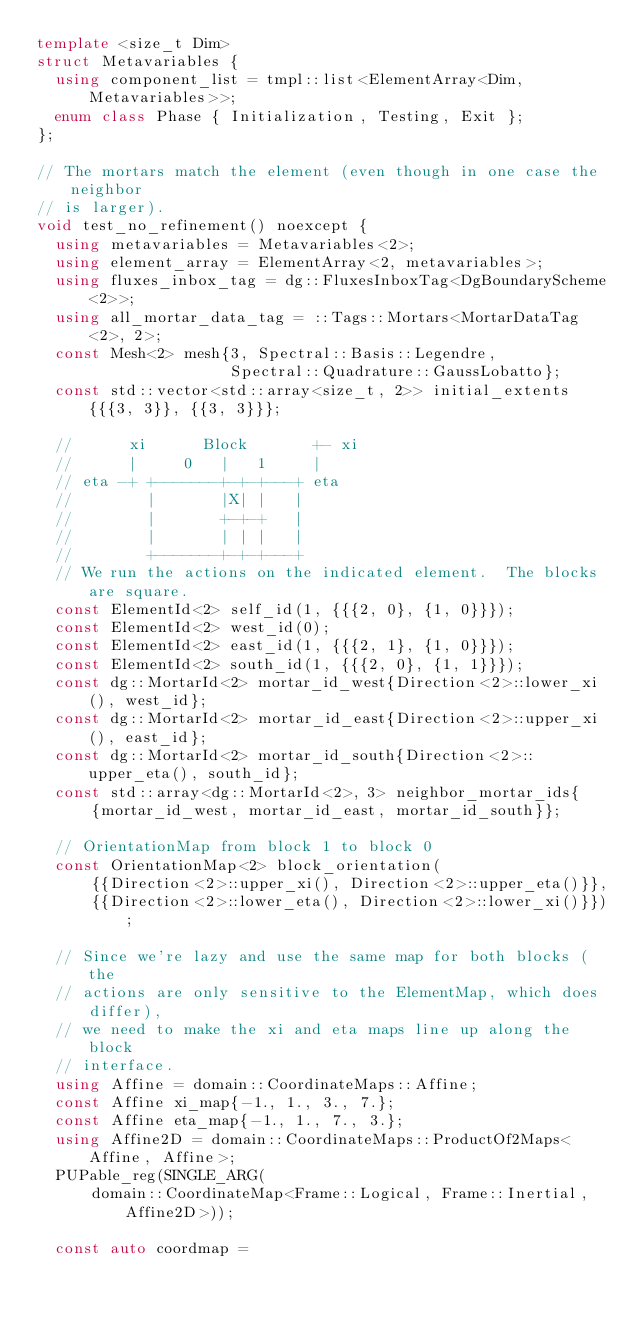<code> <loc_0><loc_0><loc_500><loc_500><_C++_>template <size_t Dim>
struct Metavariables {
  using component_list = tmpl::list<ElementArray<Dim, Metavariables>>;
  enum class Phase { Initialization, Testing, Exit };
};

// The mortars match the element (even though in one case the neighbor
// is larger).
void test_no_refinement() noexcept {
  using metavariables = Metavariables<2>;
  using element_array = ElementArray<2, metavariables>;
  using fluxes_inbox_tag = dg::FluxesInboxTag<DgBoundaryScheme<2>>;
  using all_mortar_data_tag = ::Tags::Mortars<MortarDataTag<2>, 2>;
  const Mesh<2> mesh{3, Spectral::Basis::Legendre,
                     Spectral::Quadrature::GaussLobatto};
  const std::vector<std::array<size_t, 2>> initial_extents{{{3, 3}}, {{3, 3}}};

  //      xi      Block       +- xi
  //      |     0   |   1     |
  // eta -+ +-------+-+-+---+ eta
  //        |       |X| |   |
  //        |       +-+-+   |
  //        |       | | |   |
  //        +-------+-+-+---+
  // We run the actions on the indicated element.  The blocks are square.
  const ElementId<2> self_id(1, {{{2, 0}, {1, 0}}});
  const ElementId<2> west_id(0);
  const ElementId<2> east_id(1, {{{2, 1}, {1, 0}}});
  const ElementId<2> south_id(1, {{{2, 0}, {1, 1}}});
  const dg::MortarId<2> mortar_id_west{Direction<2>::lower_xi(), west_id};
  const dg::MortarId<2> mortar_id_east{Direction<2>::upper_xi(), east_id};
  const dg::MortarId<2> mortar_id_south{Direction<2>::upper_eta(), south_id};
  const std::array<dg::MortarId<2>, 3> neighbor_mortar_ids{
      {mortar_id_west, mortar_id_east, mortar_id_south}};

  // OrientationMap from block 1 to block 0
  const OrientationMap<2> block_orientation(
      {{Direction<2>::upper_xi(), Direction<2>::upper_eta()}},
      {{Direction<2>::lower_eta(), Direction<2>::lower_xi()}});

  // Since we're lazy and use the same map for both blocks (the
  // actions are only sensitive to the ElementMap, which does differ),
  // we need to make the xi and eta maps line up along the block
  // interface.
  using Affine = domain::CoordinateMaps::Affine;
  const Affine xi_map{-1., 1., 3., 7.};
  const Affine eta_map{-1., 1., 7., 3.};
  using Affine2D = domain::CoordinateMaps::ProductOf2Maps<Affine, Affine>;
  PUPable_reg(SINGLE_ARG(
      domain::CoordinateMap<Frame::Logical, Frame::Inertial, Affine2D>));

  const auto coordmap =</code> 